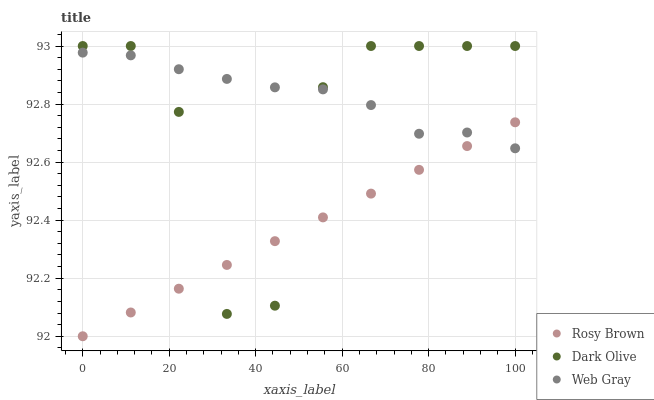Does Rosy Brown have the minimum area under the curve?
Answer yes or no. Yes. Does Web Gray have the maximum area under the curve?
Answer yes or no. Yes. Does Web Gray have the minimum area under the curve?
Answer yes or no. No. Does Rosy Brown have the maximum area under the curve?
Answer yes or no. No. Is Rosy Brown the smoothest?
Answer yes or no. Yes. Is Dark Olive the roughest?
Answer yes or no. Yes. Is Web Gray the smoothest?
Answer yes or no. No. Is Web Gray the roughest?
Answer yes or no. No. Does Rosy Brown have the lowest value?
Answer yes or no. Yes. Does Web Gray have the lowest value?
Answer yes or no. No. Does Dark Olive have the highest value?
Answer yes or no. Yes. Does Web Gray have the highest value?
Answer yes or no. No. Does Web Gray intersect Rosy Brown?
Answer yes or no. Yes. Is Web Gray less than Rosy Brown?
Answer yes or no. No. Is Web Gray greater than Rosy Brown?
Answer yes or no. No. 